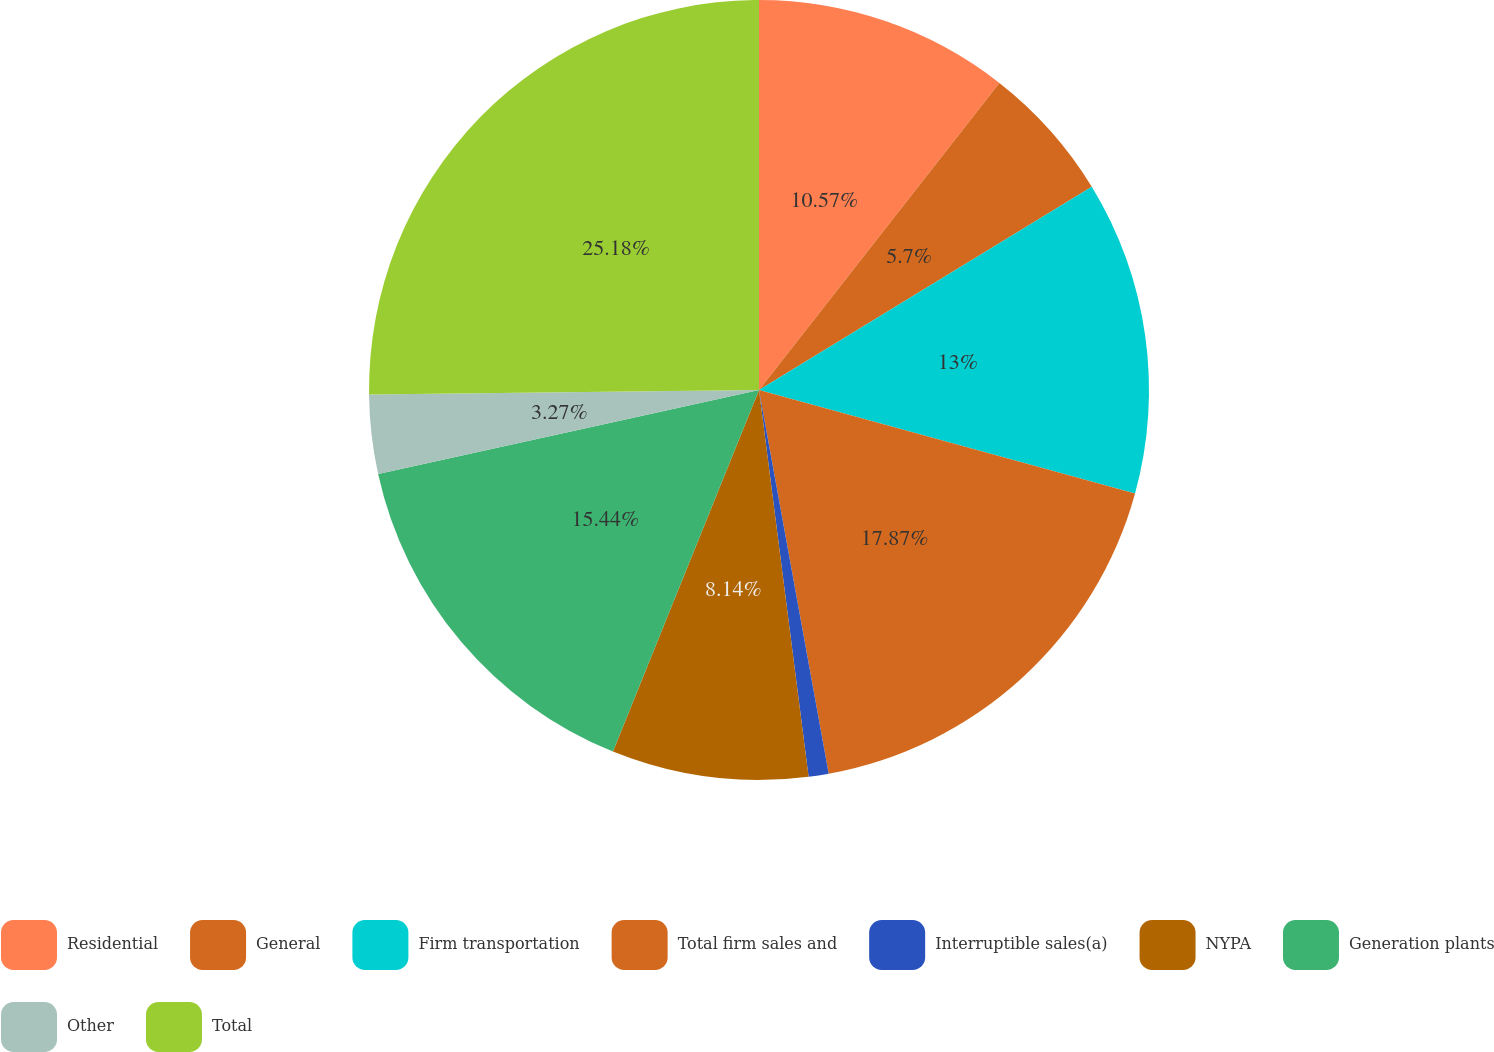<chart> <loc_0><loc_0><loc_500><loc_500><pie_chart><fcel>Residential<fcel>General<fcel>Firm transportation<fcel>Total firm sales and<fcel>Interruptible sales(a)<fcel>NYPA<fcel>Generation plants<fcel>Other<fcel>Total<nl><fcel>10.57%<fcel>5.7%<fcel>13.0%<fcel>17.87%<fcel>0.83%<fcel>8.14%<fcel>15.44%<fcel>3.27%<fcel>25.18%<nl></chart> 